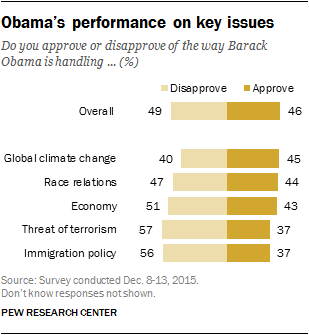Specify some key components in this picture. According to the results, 43% of respondents approve of the way Barack Obama is handling the economy. The product of two bars with similar values is 1369. 